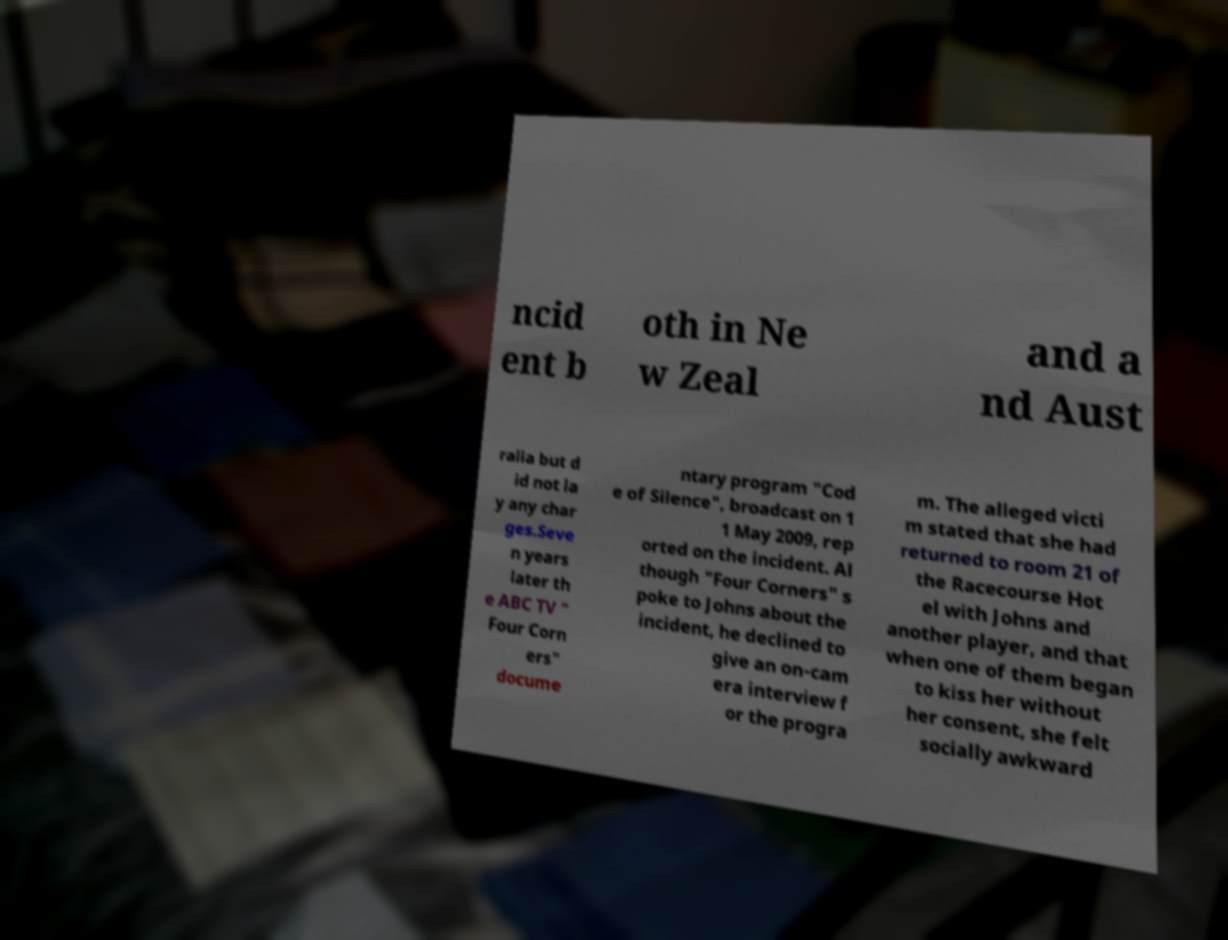Could you assist in decoding the text presented in this image and type it out clearly? ncid ent b oth in Ne w Zeal and a nd Aust ralia but d id not la y any char ges.Seve n years later th e ABC TV " Four Corn ers" docume ntary program "Cod e of Silence", broadcast on 1 1 May 2009, rep orted on the incident. Al though "Four Corners" s poke to Johns about the incident, he declined to give an on-cam era interview f or the progra m. The alleged victi m stated that she had returned to room 21 of the Racecourse Hot el with Johns and another player, and that when one of them began to kiss her without her consent, she felt socially awkward 